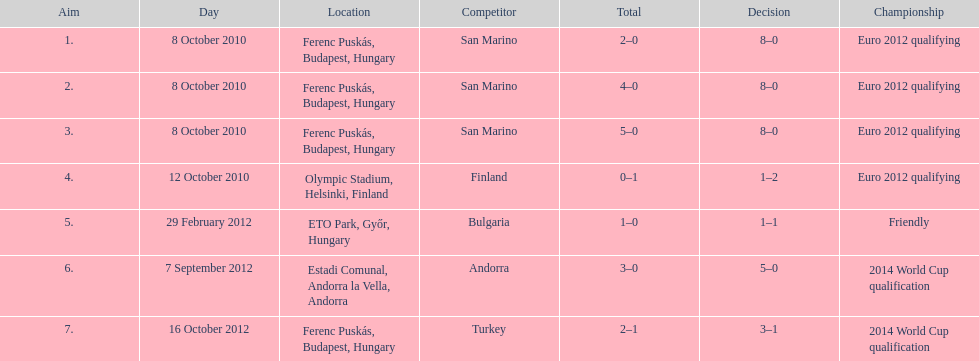What is the number of goals ádám szalai made against san marino in 2010? 3. 